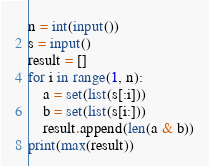<code> <loc_0><loc_0><loc_500><loc_500><_Python_>n = int(input())
s = input()
result = []
for i in range(1, n):
    a = set(list(s[:i]))
    b = set(list(s[i:]))
    result.append(len(a & b))
print(max(result))</code> 